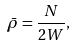Convert formula to latex. <formula><loc_0><loc_0><loc_500><loc_500>\bar { \rho } = \frac { N } { 2 W } ,</formula> 